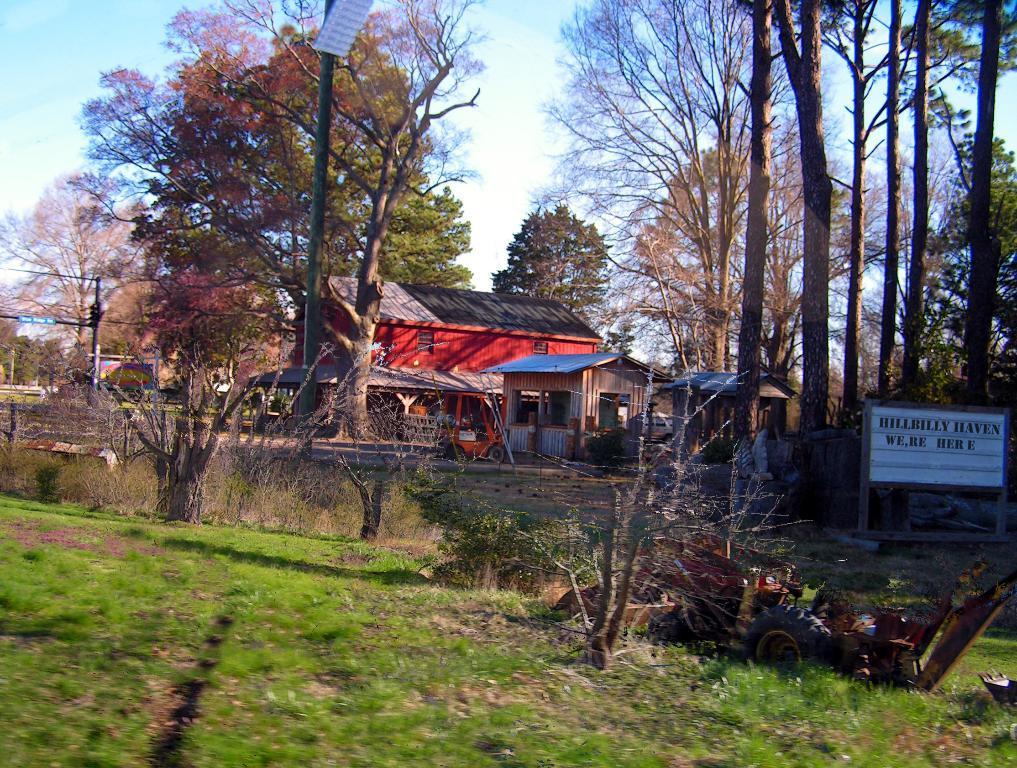How would you summarize this image in a sentence or two? In the center of the image we can see some huts, trees, boards are there. At the top of the image sky is present. At the bottom of the image grass is there. In the middle of the image ground is there. On the left side of the image pole is there. On the right side of the image a vehicle is present. 